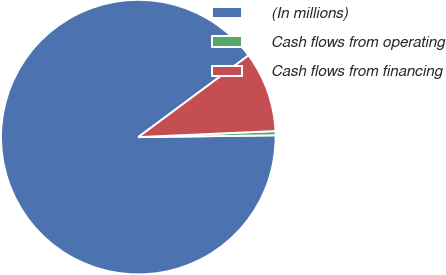<chart> <loc_0><loc_0><loc_500><loc_500><pie_chart><fcel>(In millions)<fcel>Cash flows from operating<fcel>Cash flows from financing<nl><fcel>90.06%<fcel>0.49%<fcel>9.45%<nl></chart> 